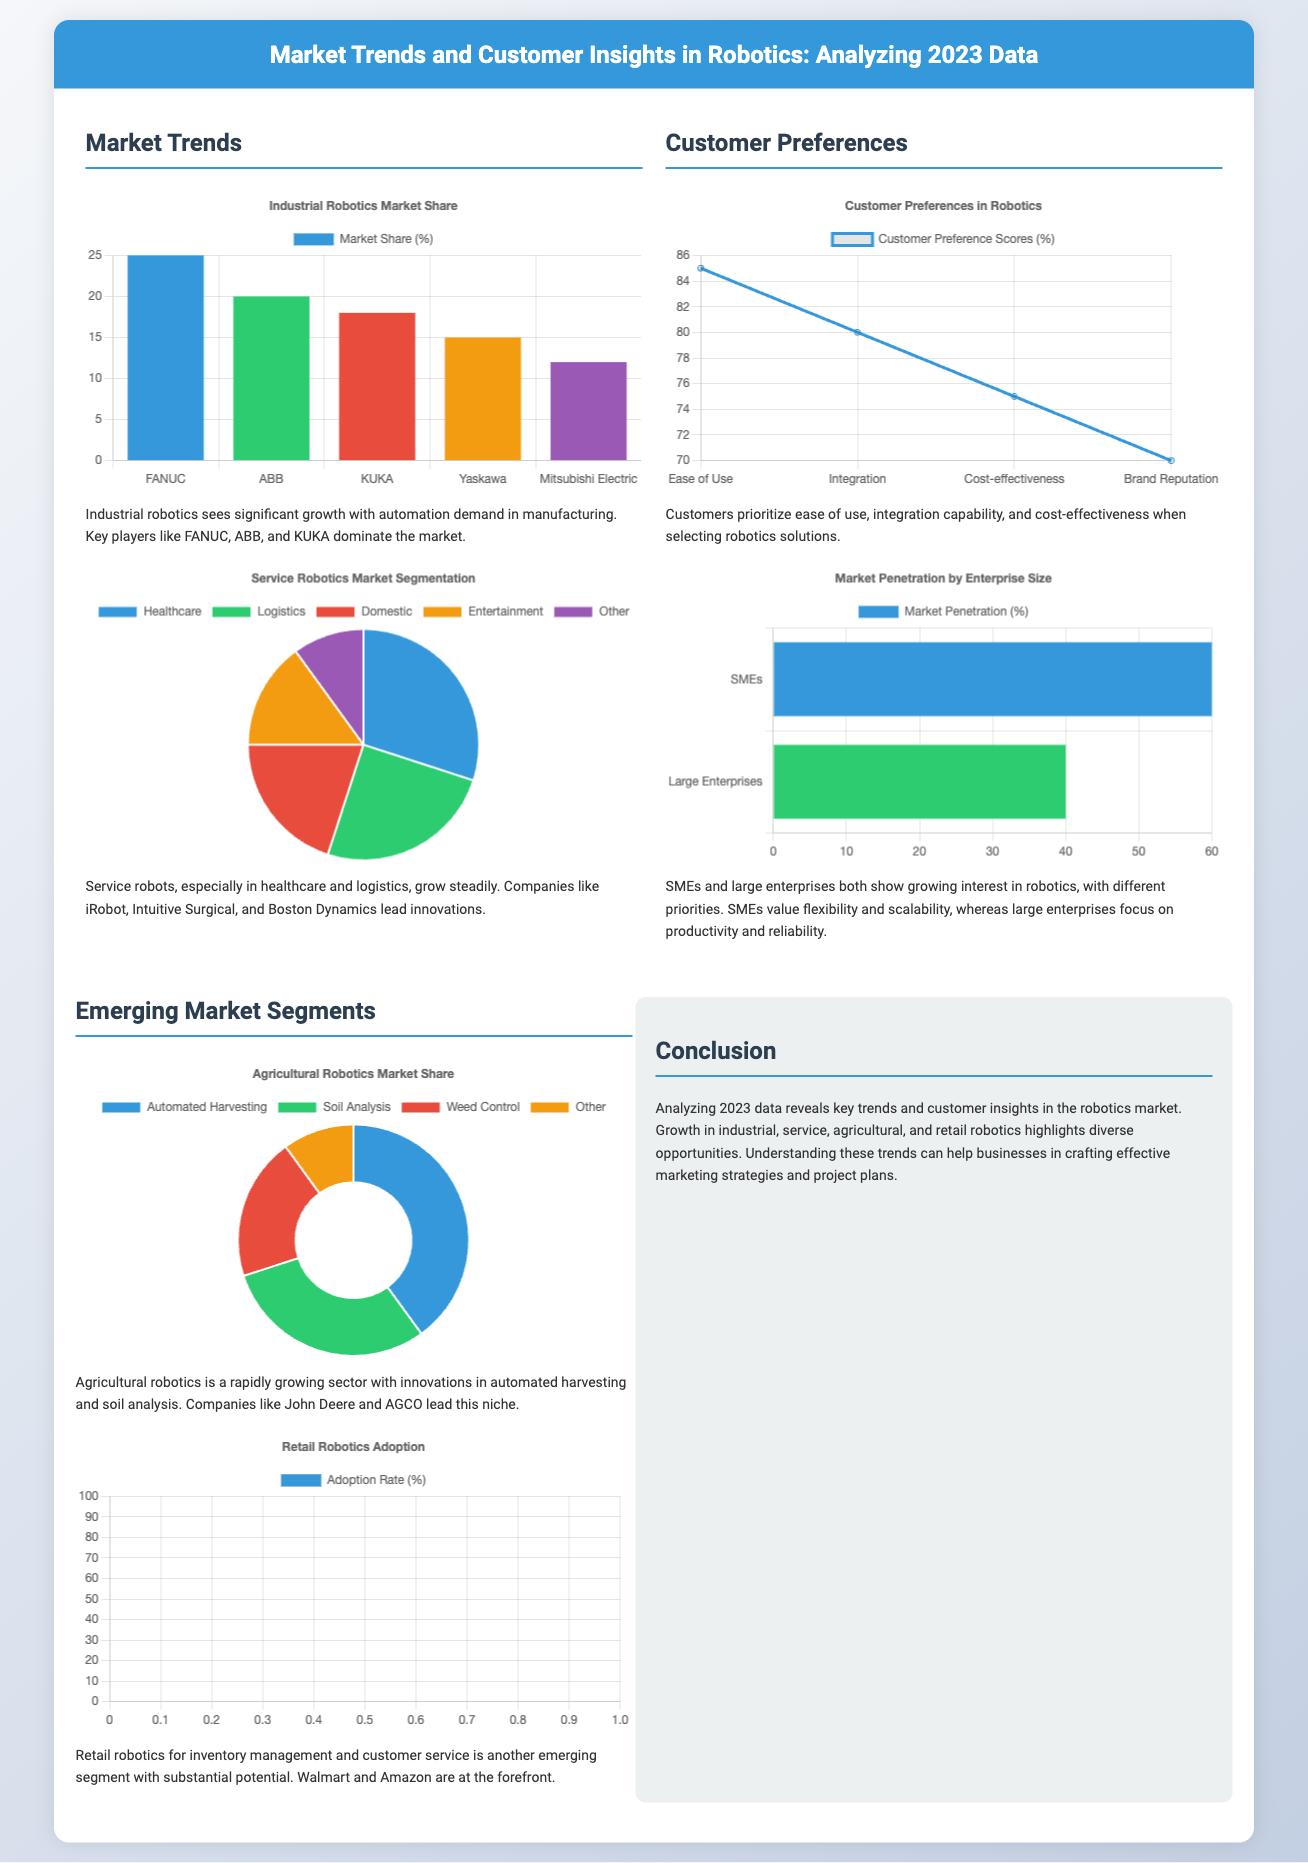What is the market share of FANUC in industrial robotics? The document lists FANUC's market share in industrial robotics as 25%.
Answer: 25% Which companies lead in service robotics, particularly in healthcare? The document mentions iRobot and Intuitive Surgical as leaders in healthcare robotics.
Answer: iRobot, Intuitive Surgical What are the top three customer preferences in robotics solutions? Customer preferences highlighted are ease of use, integration capability, and cost-effectiveness.
Answer: Ease of Use, Integration, Cost-effectiveness What percentage of market penetration do SMEs have compared to large enterprises? The document provides penetration rates of 60% for SMEs and 40% for large enterprises.
Answer: 60%, 40% Which segment of robotics sees rapid growth due to innovations in automated harvesting? The document indicates that agricultural robotics is experiencing rapid growth.
Answer: Agricultural Robotics What type of chart represents the market share for retail robotics? A scatter chart is used to represent the adoption rate for retail robotics.
Answer: Scatter What percentage of the market share does automated harvesting represent in agricultural robotics? The document states that automated harvesting occupies 40% of the agricultural robotics market.
Answer: 40% Which two companies are at the forefront of retail robotics? The document mentions Walmart and Amazon as leading companies in retail robotics.
Answer: Walmart, Amazon What feature do customers prioritize most when selecting robotics solutions? The most prioritized feature by customers is ease of use.
Answer: Ease of Use 